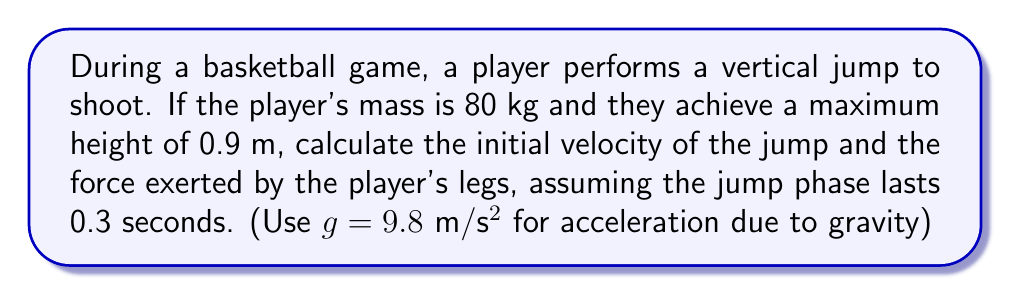Can you answer this question? To solve this problem, we'll use principles of kinematics and Newton's laws of motion. Let's break it down step-by-step:

1. Calculate the initial velocity:
   We can use the equation for maximum height in a vertical jump:
   $$ h = \frac{v_0^2}{2g} $$
   where $h$ is the maximum height, $v_0$ is the initial velocity, and $g$ is the acceleration due to gravity.

   Rearranging this equation:
   $$ v_0 = \sqrt{2gh} $$
   $$ v_0 = \sqrt{2 \cdot 9.8 \cdot 0.9} = 4.2 \text{ m/s} $$

2. Calculate the force exerted by the player's legs:
   We'll use Newton's Second Law of Motion: $F = ma$

   First, we need to find the acceleration during the jump phase:
   Initial velocity: $v_0 = 4.2 \text{ m/s}$
   Final velocity: $v = 0 \text{ m/s}$ (at the top of the jump)
   Time: $t = 0.3 \text{ s}$

   Using the equation for acceleration:
   $$ a = \frac{v - v_0}{t} = \frac{0 - 4.2}{0.3} = -14 \text{ m/s²} $$

   The negative sign indicates deceleration, but we're interested in the magnitude.

   Now we can calculate the force:
   $$ F = ma = 80 \cdot 14 = 1120 \text{ N} $$

   This is the additional force beyond the player's weight. The total force exerted by the legs is:
   $$ F_{\text{total}} = F + mg = 1120 + (80 \cdot 9.8) = 1904 \text{ N} $$
Answer: The initial velocity of the jump is 4.2 m/s, and the total force exerted by the player's legs is 1904 N. 